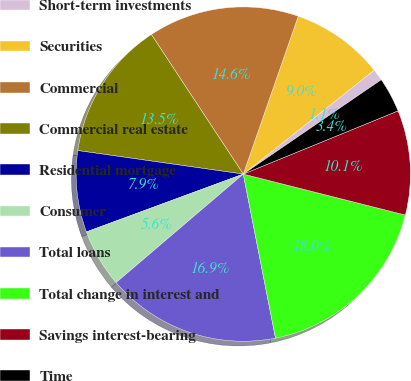Convert chart. <chart><loc_0><loc_0><loc_500><loc_500><pie_chart><fcel>Short-term investments<fcel>Securities<fcel>Commercial<fcel>Commercial real estate<fcel>Residential mortgage<fcel>Consumer<fcel>Total loans<fcel>Total change in interest and<fcel>Savings interest-bearing<fcel>Time<nl><fcel>1.13%<fcel>8.99%<fcel>14.6%<fcel>13.48%<fcel>7.87%<fcel>5.62%<fcel>16.85%<fcel>17.97%<fcel>10.11%<fcel>3.38%<nl></chart> 